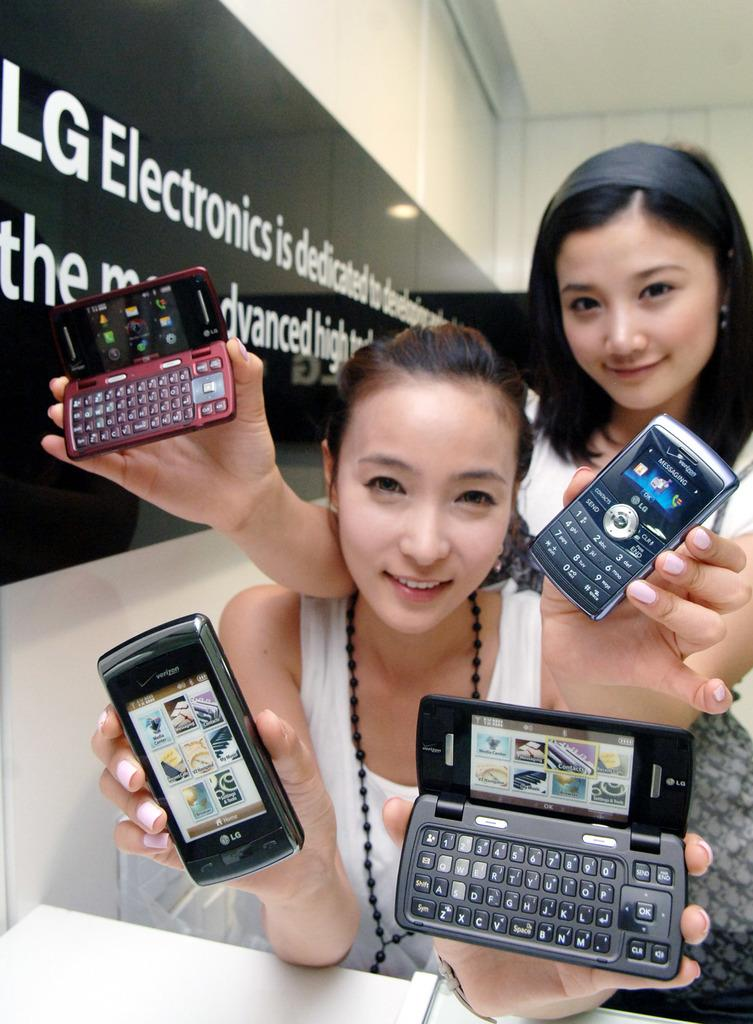<image>
Create a compact narrative representing the image presented. Two girls are holding up four cell phones by a sign that says LG Electronics. 